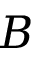Convert formula to latex. <formula><loc_0><loc_0><loc_500><loc_500>B</formula> 